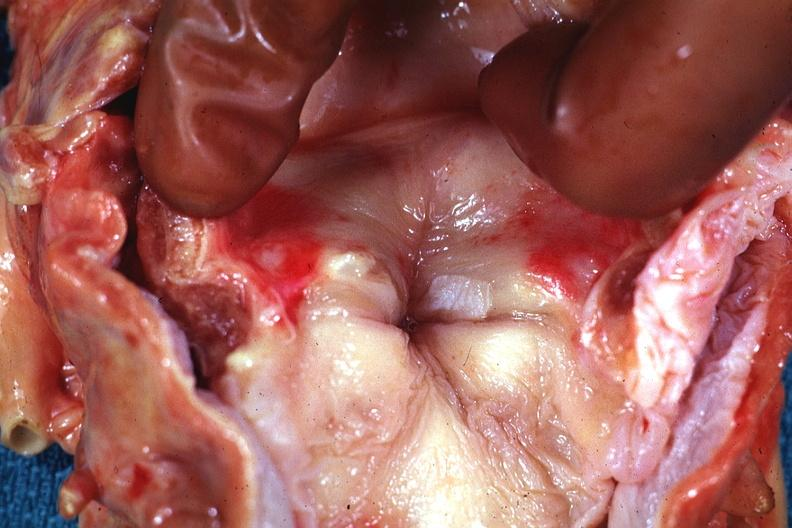what does this image show?
Answer the question using a single word or phrase. Shows lesion quite well in opened larynx 